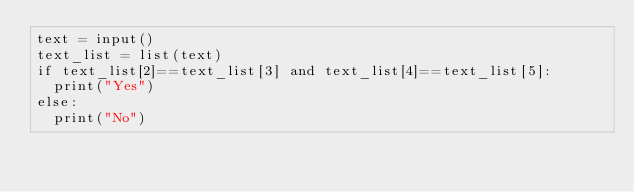<code> <loc_0><loc_0><loc_500><loc_500><_Python_>text = input()
text_list = list(text)
if text_list[2]==text_list[3] and text_list[4]==text_list[5]:
  print("Yes")
else:
  print("No")</code> 